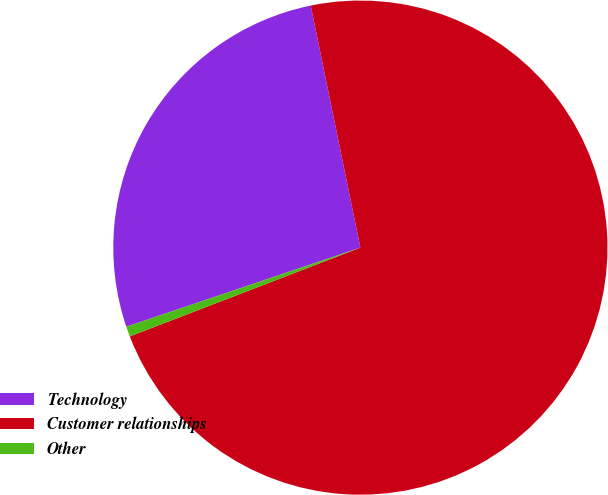Convert chart. <chart><loc_0><loc_0><loc_500><loc_500><pie_chart><fcel>Technology<fcel>Customer relationships<fcel>Other<nl><fcel>26.97%<fcel>72.37%<fcel>0.66%<nl></chart> 